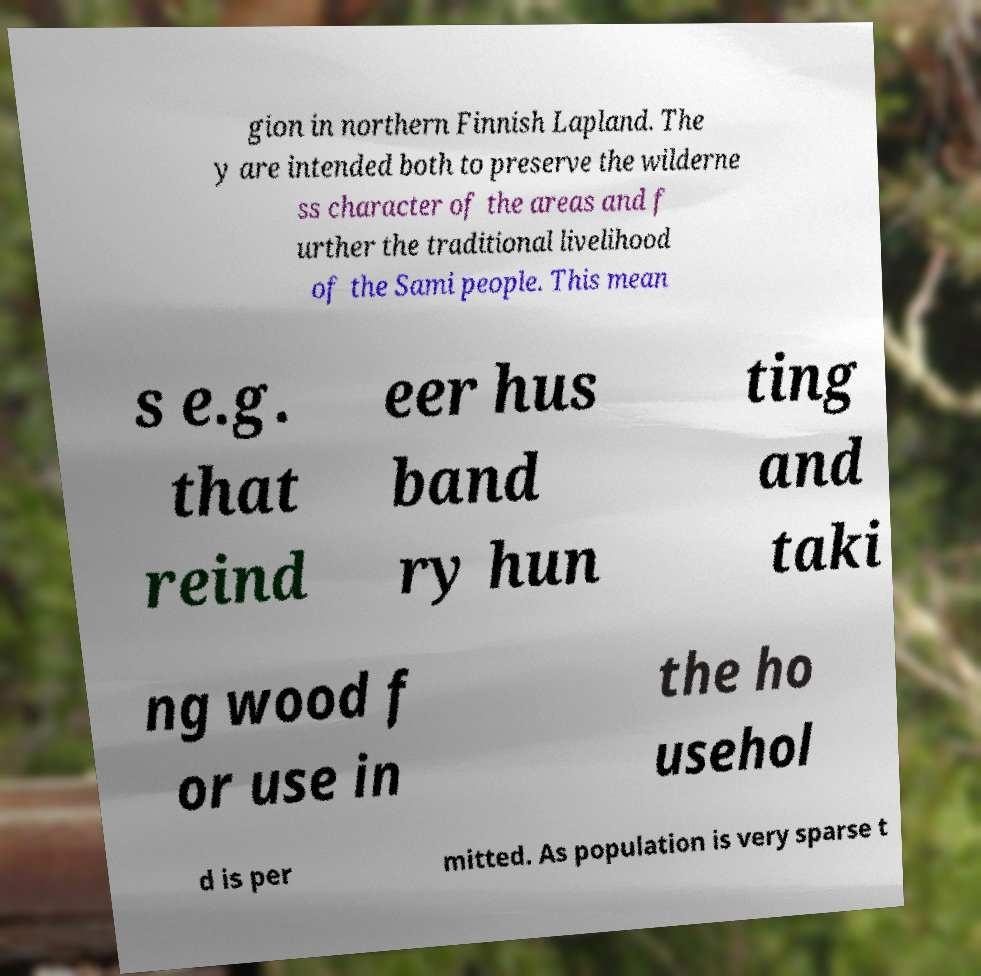Could you extract and type out the text from this image? gion in northern Finnish Lapland. The y are intended both to preserve the wilderne ss character of the areas and f urther the traditional livelihood of the Sami people. This mean s e.g. that reind eer hus band ry hun ting and taki ng wood f or use in the ho usehol d is per mitted. As population is very sparse t 